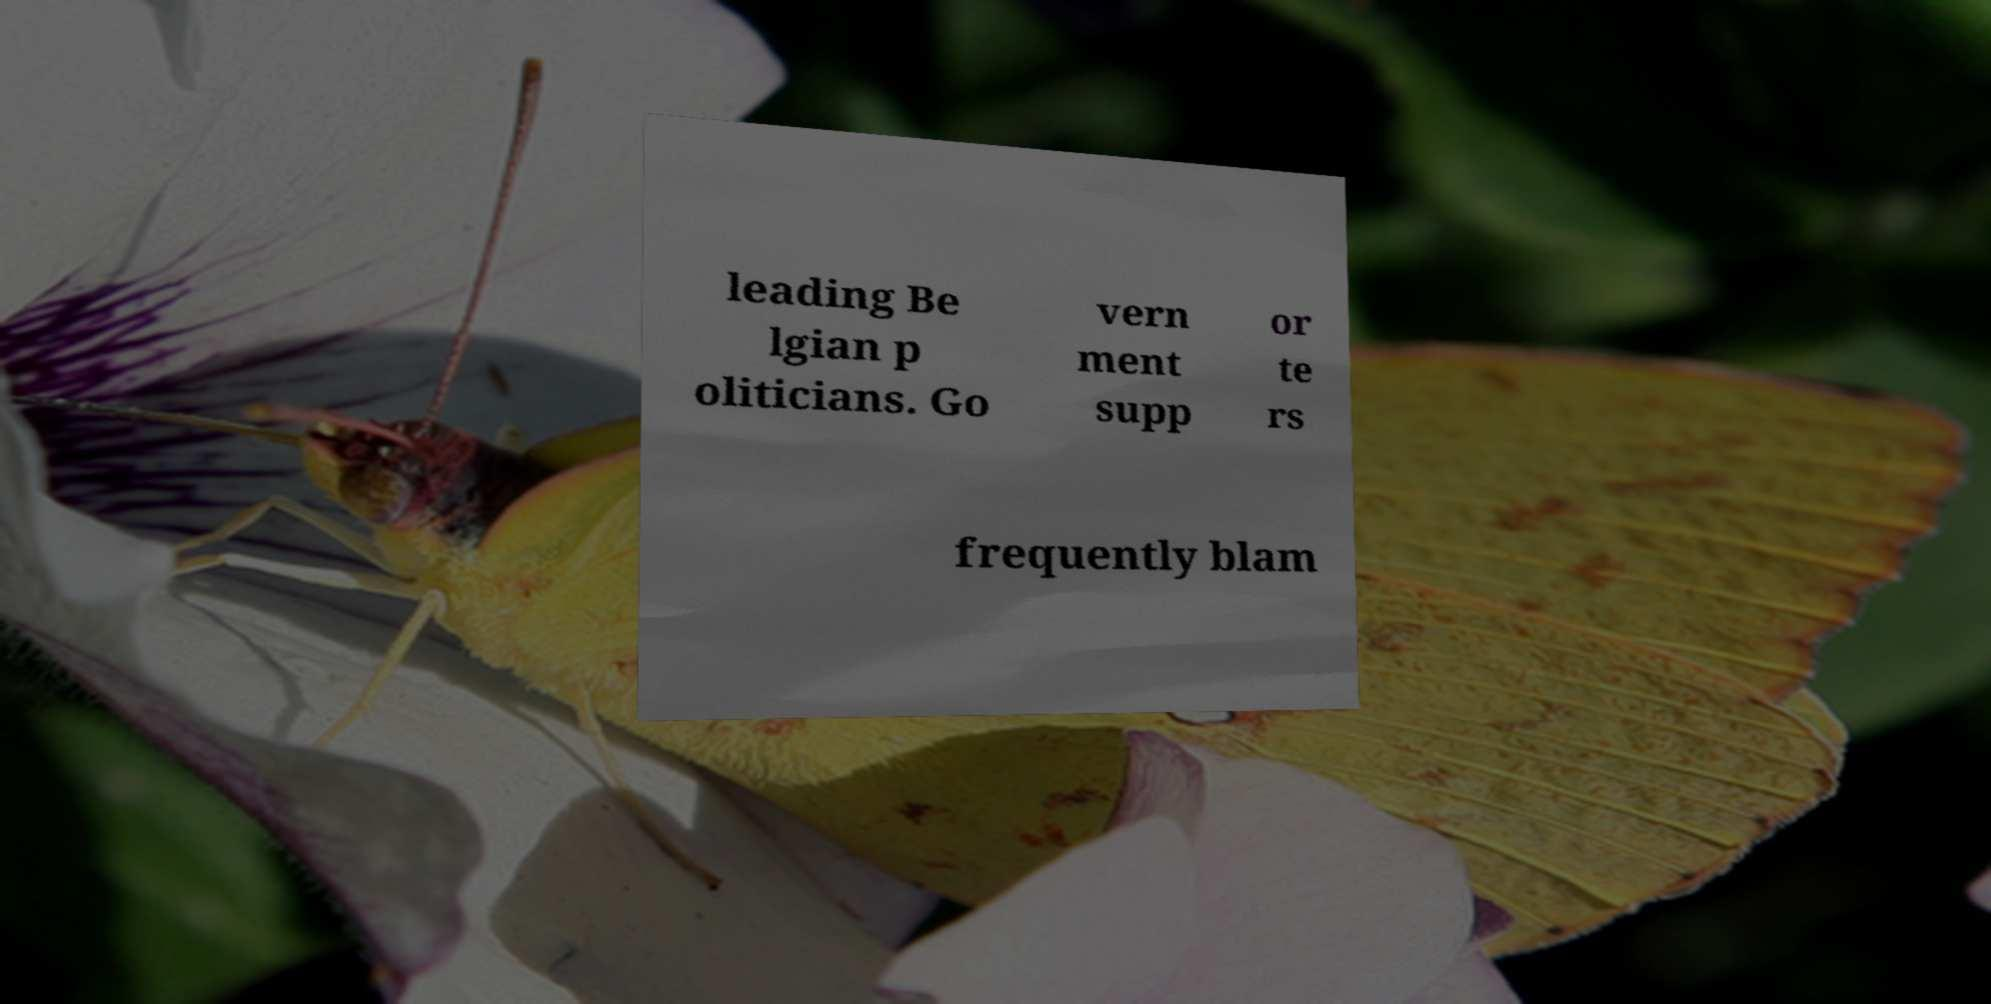I need the written content from this picture converted into text. Can you do that? leading Be lgian p oliticians. Go vern ment supp or te rs frequently blam 